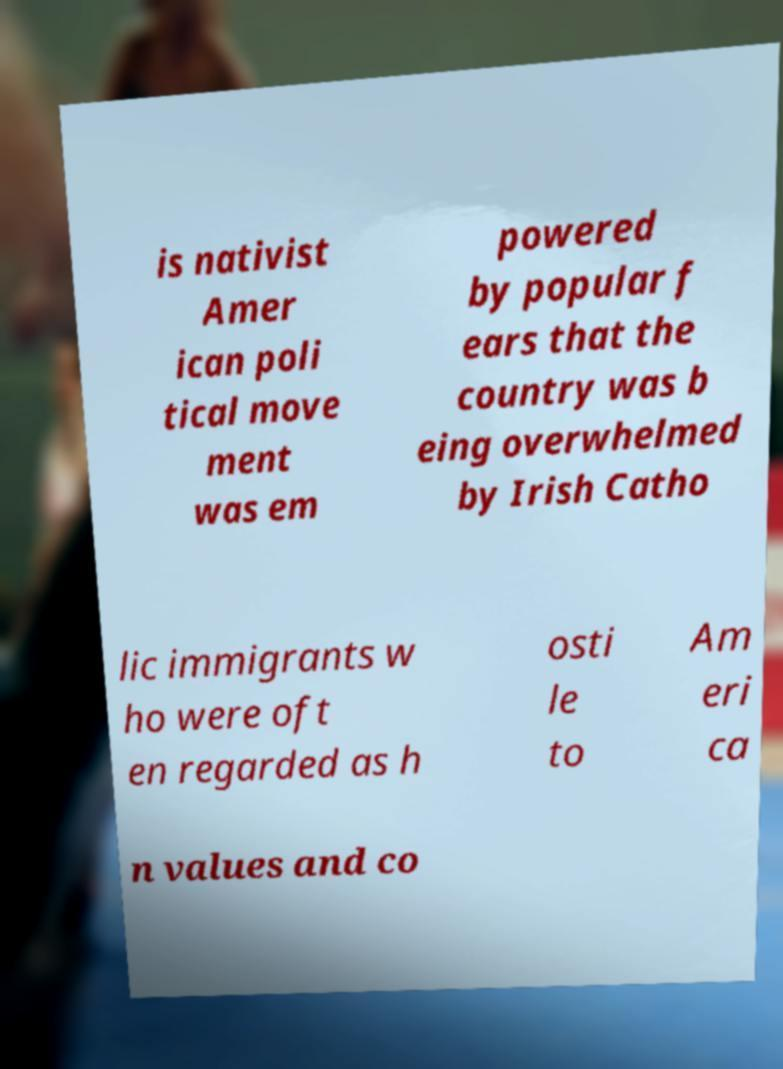There's text embedded in this image that I need extracted. Can you transcribe it verbatim? is nativist Amer ican poli tical move ment was em powered by popular f ears that the country was b eing overwhelmed by Irish Catho lic immigrants w ho were oft en regarded as h osti le to Am eri ca n values and co 